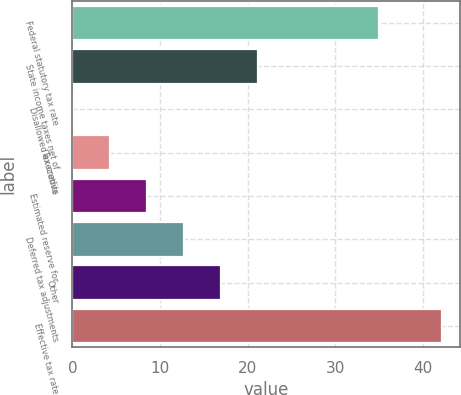Convert chart. <chart><loc_0><loc_0><loc_500><loc_500><bar_chart><fcel>Federal statutory tax rate<fcel>State income taxes net of<fcel>Disallowed executive<fcel>Tax credits<fcel>Estimated reserve for<fcel>Deferred tax adjustments<fcel>Other<fcel>Effective tax rate<nl><fcel>35<fcel>21.15<fcel>0.1<fcel>4.31<fcel>8.52<fcel>12.73<fcel>16.94<fcel>42.2<nl></chart> 